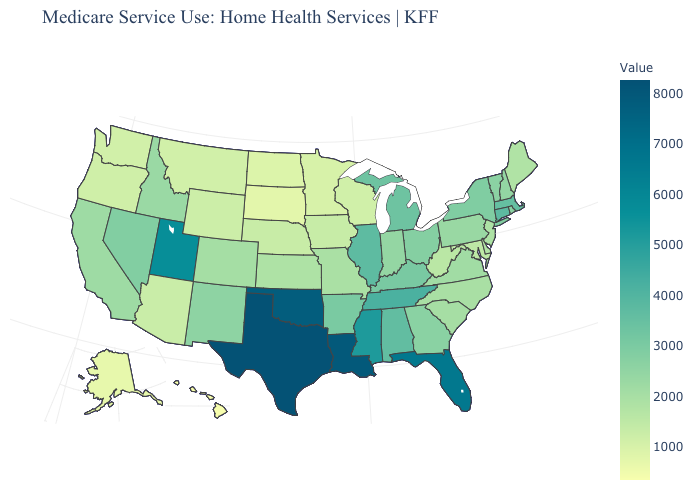Which states have the lowest value in the West?
Write a very short answer. Hawaii. Does Iowa have a lower value than Hawaii?
Be succinct. No. Does West Virginia have a higher value than Mississippi?
Be succinct. No. 